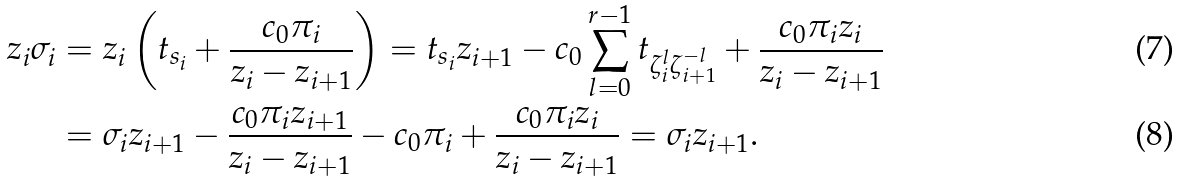Convert formula to latex. <formula><loc_0><loc_0><loc_500><loc_500>z _ { i } \sigma _ { i } & = z _ { i } \left ( t _ { s _ { i } } + \frac { c _ { 0 } \pi _ { i } } { z _ { i } - z _ { i + 1 } } \right ) = t _ { s _ { i } } z _ { i + 1 } - c _ { 0 } \sum _ { l = 0 } ^ { r - 1 } t _ { \zeta _ { i } ^ { l } \zeta _ { i + 1 } ^ { - l } } + \frac { c _ { 0 } \pi _ { i } z _ { i } } { z _ { i } - z _ { i + 1 } } \\ & = \sigma _ { i } z _ { i + 1 } - \frac { c _ { 0 } \pi _ { i } z _ { i + 1 } } { z _ { i } - z _ { i + 1 } } - c _ { 0 } \pi _ { i } + \frac { c _ { 0 } \pi _ { i } z _ { i } } { z _ { i } - z _ { i + 1 } } = \sigma _ { i } z _ { i + 1 } .</formula> 